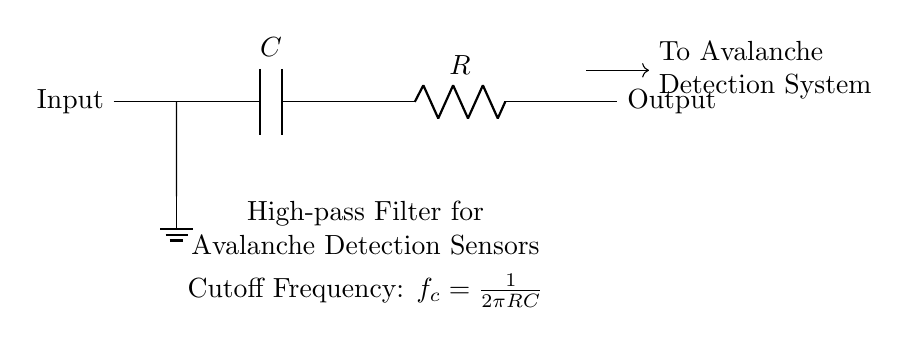What are the components in this circuit? The circuit consists of a capacitor and a resistor, as indicated by the symbols used within the diagram.
Answer: Capacitor and Resistor What is the input of the circuit? The circuit diagram clearly labels the left side as the input, where the signal is introduced into the system.
Answer: Input What is the output of the circuit? The diagram specifies the right side as the output, indicating where the processed signal exits the circuit.
Answer: Output What type of filter is represented in this circuit? The circuit is identified as a high-pass filter based on its configuration and the description provided below the circuit.
Answer: High-pass filter What is the formula for the cutoff frequency? The circuit diagram includes a specific formula for calculating the cutoff frequency, which is shown clearly as a mathematical expression beneath the circuit.
Answer: f_c = 1/(2πRC) How does the resistor affect the signal in this circuit? The resistor in a high-pass filter configuration works with the capacitor to determine the cutoff frequency, influencing the frequencies that can pass through.
Answer: It influences cutoff frequency What happens to low-frequency signals in this circuit? By the nature of a high-pass filter, low-frequency signals are attenuated or blocked, allowing higher frequencies to pass through effectively.
Answer: Attenuated or blocked 